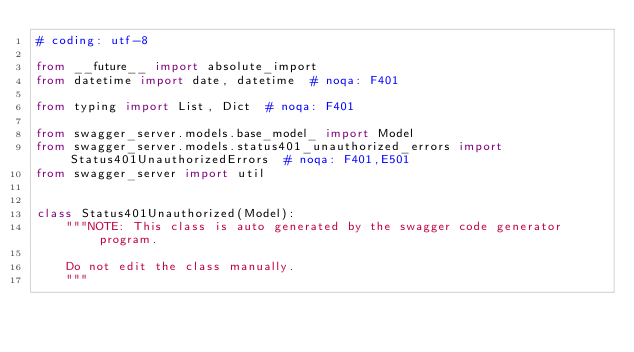<code> <loc_0><loc_0><loc_500><loc_500><_Python_># coding: utf-8

from __future__ import absolute_import
from datetime import date, datetime  # noqa: F401

from typing import List, Dict  # noqa: F401

from swagger_server.models.base_model_ import Model
from swagger_server.models.status401_unauthorized_errors import Status401UnauthorizedErrors  # noqa: F401,E501
from swagger_server import util


class Status401Unauthorized(Model):
    """NOTE: This class is auto generated by the swagger code generator program.

    Do not edit the class manually.
    """</code> 